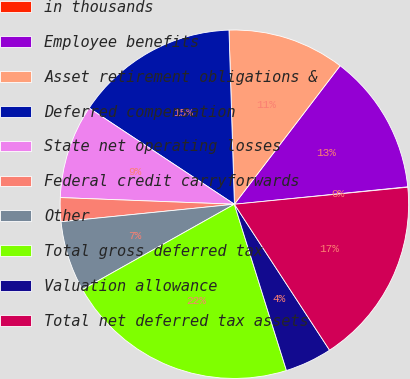<chart> <loc_0><loc_0><loc_500><loc_500><pie_chart><fcel>in thousands<fcel>Employee benefits<fcel>Asset retirement obligations &<fcel>Deferred compensation<fcel>State net operating losses<fcel>Federal credit carryforwards<fcel>Other<fcel>Total gross deferred tax<fcel>Valuation allowance<fcel>Total net deferred tax assets<nl><fcel>0.04%<fcel>13.03%<fcel>10.87%<fcel>15.2%<fcel>8.7%<fcel>2.21%<fcel>6.54%<fcel>21.69%<fcel>4.37%<fcel>17.36%<nl></chart> 